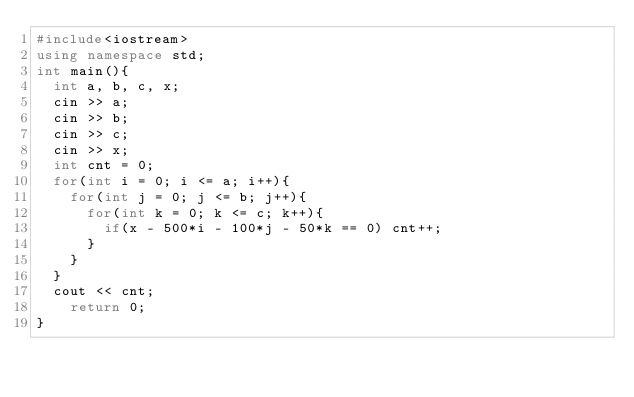<code> <loc_0><loc_0><loc_500><loc_500><_C++_>#include<iostream>
using namespace std;
int main(){
  int a, b, c, x;
  cin >> a;
  cin >> b;
  cin >> c;
  cin >> x;
  int cnt = 0;
  for(int i = 0; i <= a; i++){
    for(int j = 0; j <= b; j++){
      for(int k = 0; k <= c; k++){
        if(x - 500*i - 100*j - 50*k == 0) cnt++;
      }
    }
  }
  cout << cnt;
    return 0;
}</code> 